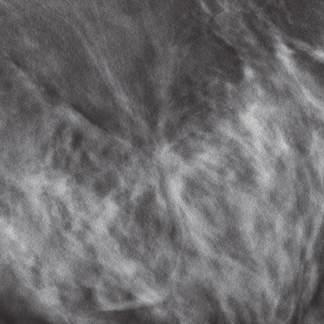what do lobular carcinomas offen appear as?
Answer the question using a single word or phrase. Relatively subtle 